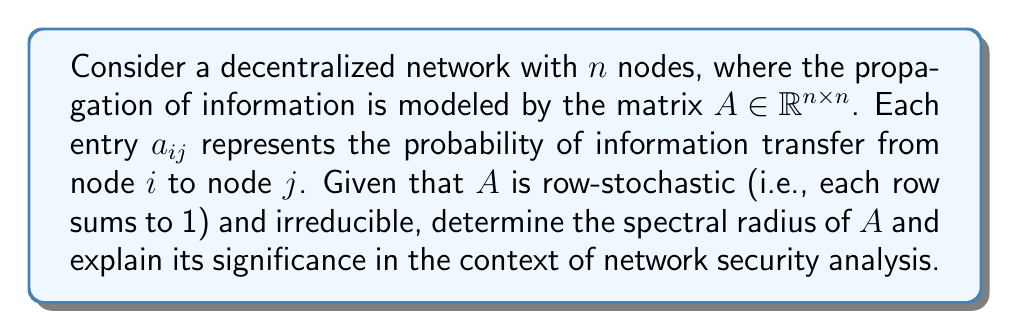Provide a solution to this math problem. To solve this problem, we'll follow these steps:

1) Recall that for a square matrix $A$, the spectral radius $\rho(A)$ is defined as:

   $$\rho(A) = \max\{|\lambda| : \lambda \text{ is an eigenvalue of } A\}$$

2) For a row-stochastic matrix, we know that:
   
   a) All eigenvalues $\lambda$ satisfy $|\lambda| \leq 1$
   b) 1 is always an eigenvalue

3) Since $A$ is irreducible and row-stochastic, we can apply the Perron-Frobenius theorem, which states that:

   a) The spectral radius $\rho(A) = 1$
   b) 1 is a simple eigenvalue (i.e., its algebraic multiplicity is 1)
   c) There exists a unique (up to scaling) positive eigenvector $v$ corresponding to the eigenvalue 1

4) In the context of network security analysis, this result has significant implications:

   a) The spectral radius being 1 indicates that the network will reach a stable state in the long run, regardless of the initial distribution of information.
   
   b) The eigenvector $v$ corresponding to the eigenvalue 1 represents the stationary distribution of the network. In security terms, this could represent the long-term vulnerability or importance of each node in the network.
   
   c) The rate of convergence to this stationary distribution is governed by the second largest eigenvalue in magnitude. The smaller this value, the faster the network converges, which could be crucial for understanding how quickly security information or threats propagate through the network.

5) For security analysis, this spectral radius and the associated eigenvector can be used to:

   a) Identify critical nodes in the network that may require extra protection
   b) Understand the long-term behavior of information or threat propagation
   c) Analyze the network's resilience to attacks or information manipulation

Therefore, determining that the spectral radius is 1 for this network propagation operator provides valuable insights for security analysis in decentralized networks.
Answer: The spectral radius of the network propagation operator $A$ is 1. 